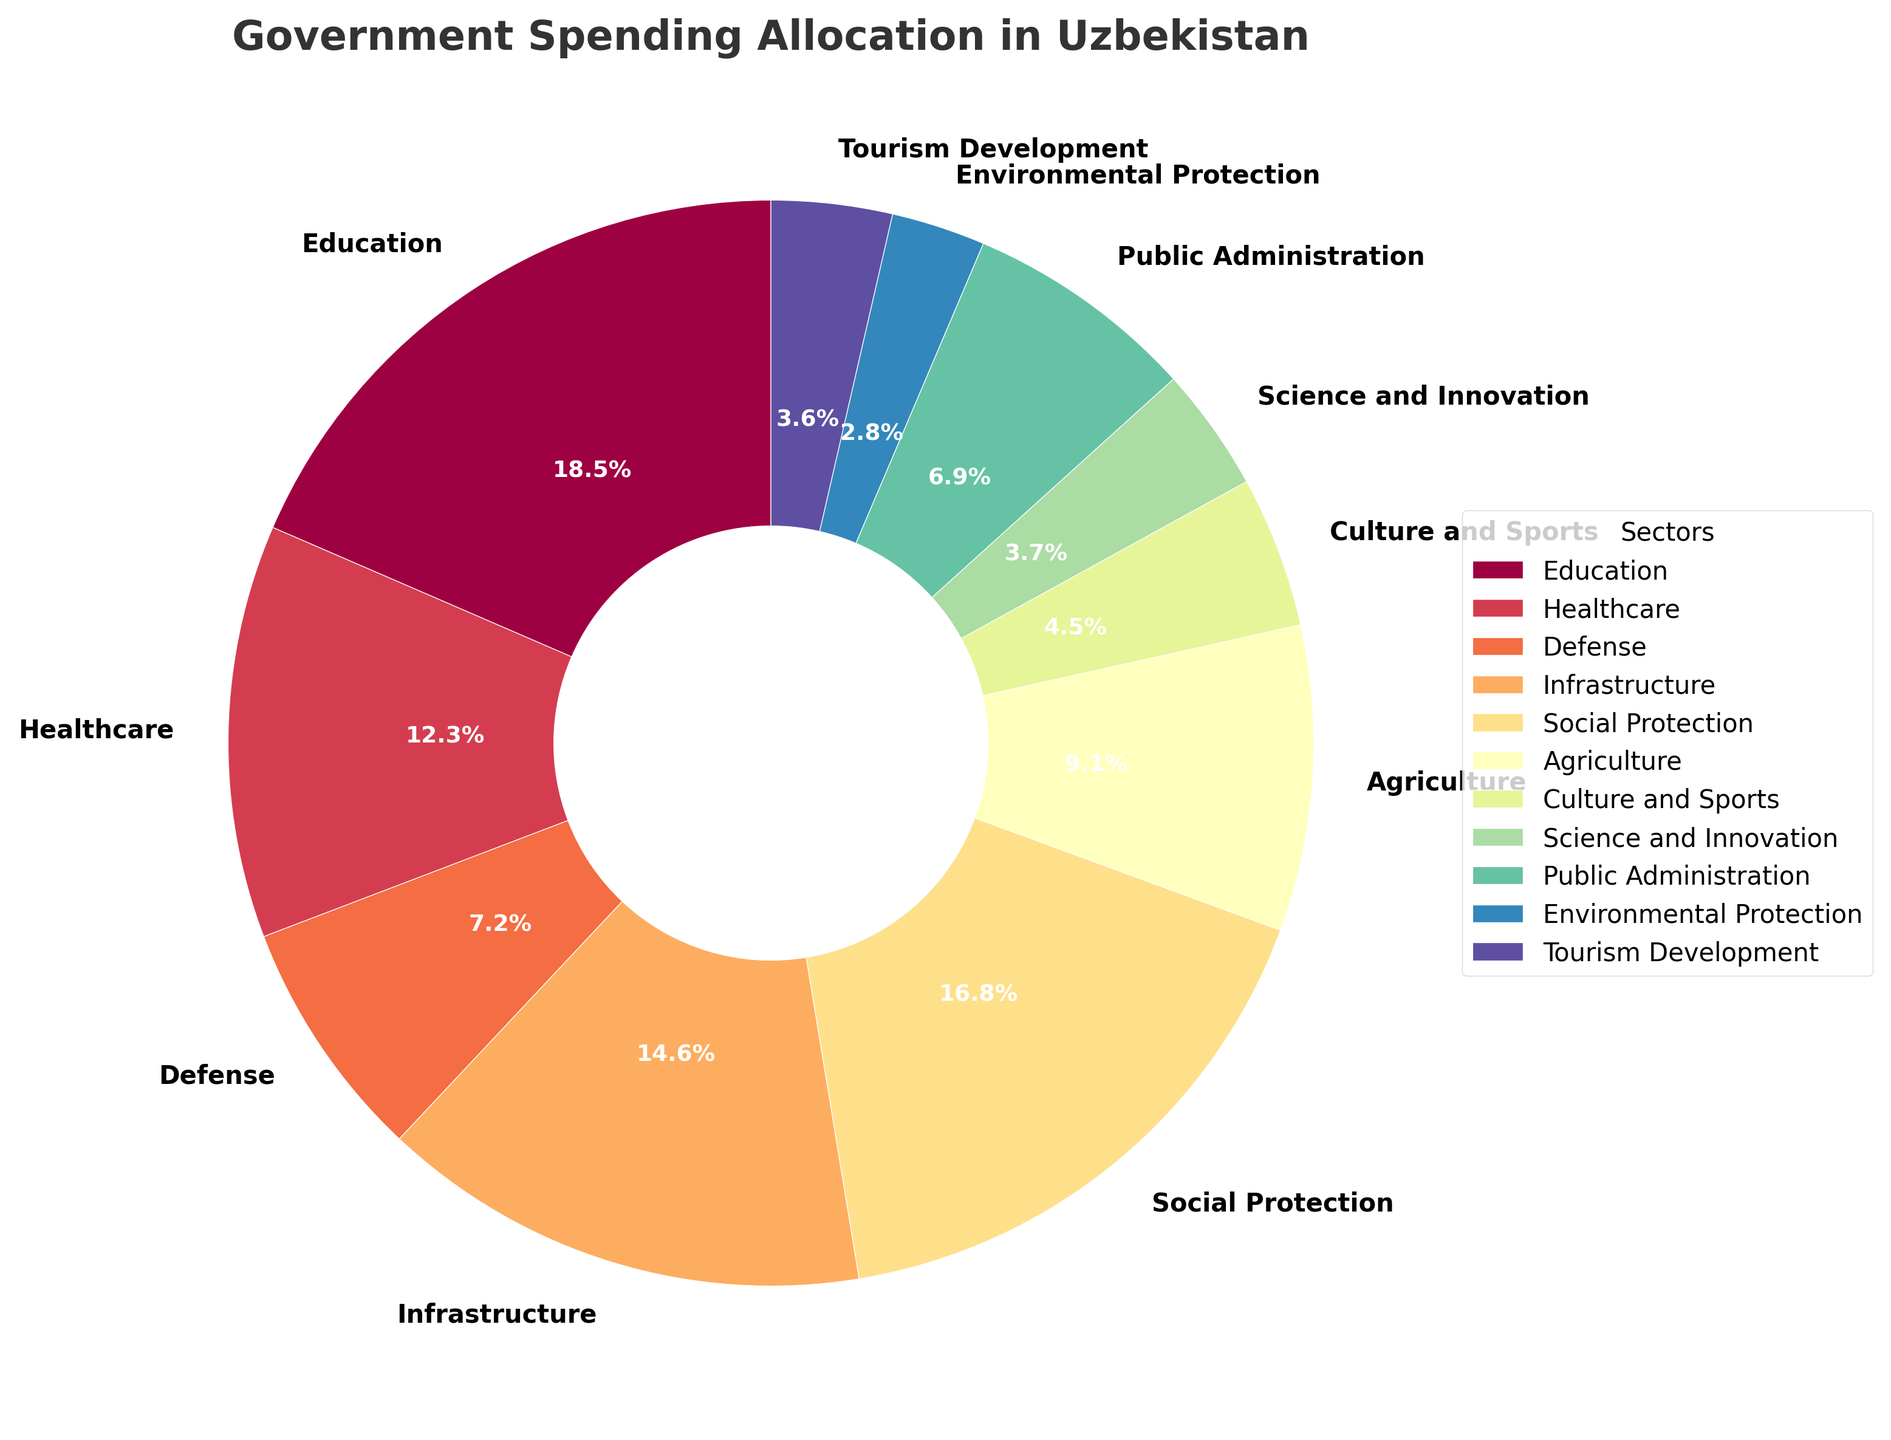What sector receives the largest allocation of government spending? To identify the sector with the largest allocation, we should look for the sector with the highest percentage in the pie chart. "Education" stands out with 18.5%.
Answer: Education What is the combined allocation for Healthcare and Infrastructure? To find the combined allocation for Healthcare and Infrastructure, add the percentages for these two sectors: 12.3% (Healthcare) + 14.6% (Infrastructure) = 26.9%.
Answer: 26.9% Which sector gets less funding, Public Administration or Defense? By comparing the percentages, Public Administration has 6.9% while Defense has 7.2%. Since 6.9% < 7.2%, Public Administration gets less funding.
Answer: Public Administration What is the difference in allocation between Agriculture and Culture and Sports? To find the difference, subtract the percentage for Culture and Sports from the percentage for Agriculture: 9.1% - 4.5% = 4.6%.
Answer: 4.6% Which sector has the least allocation, and what is its percentage? Identify the smallest percentage in the pie chart. "Environmental Protection" has the least allocation with 2.8%.
Answer: Environmental Protection, 2.8% What is the total percentage allocated to sectors related to education, science, and culture? Sum up the percentages for Education (18.5%), Science and Innovation (3.7%), and Culture and Sports (4.5%): 18.5% + 3.7% + 4.5% = 26.7%.
Answer: 26.7% How does the allocation for Social Protection compare to that for Agriculture? Compare the percentages directly: Social Protection has 16.8% while Agriculture has 9.1%. Since 16.8% > 9.1%, Social Protection receives more allocation.
Answer: Social Protection receives more How much more does Infrastructure receive compared to Tourism Development? Subtract the percentage for Tourism Development from the percentage for Infrastructure: 14.6% - 3.6% = 11.0%.
Answer: 11.0% Is the allocation for Science and Innovation greater than that for Tourism Development? Compare the percentages of both sectors: Science and Innovation has 3.7%, while Tourism Development has 3.6%. Since 3.7% > 3.6%, Science and Innovation is greater.
Answer: Yes What percentage of the total budget is allocated to sectors other than Education and Healthcare? Subtract the combined percentage of Education and Healthcare from 100%: 100% - (18.5% + 12.3%) = 100% - 30.8% = 69.2%.
Answer: 69.2% 